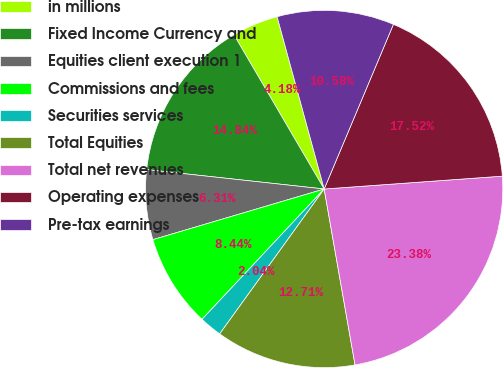Convert chart to OTSL. <chart><loc_0><loc_0><loc_500><loc_500><pie_chart><fcel>in millions<fcel>Fixed Income Currency and<fcel>Equities client execution 1<fcel>Commissions and fees<fcel>Securities services<fcel>Total Equities<fcel>Total net revenues<fcel>Operating expenses<fcel>Pre-tax earnings<nl><fcel>4.18%<fcel>14.84%<fcel>6.31%<fcel>8.44%<fcel>2.04%<fcel>12.71%<fcel>23.38%<fcel>17.52%<fcel>10.58%<nl></chart> 